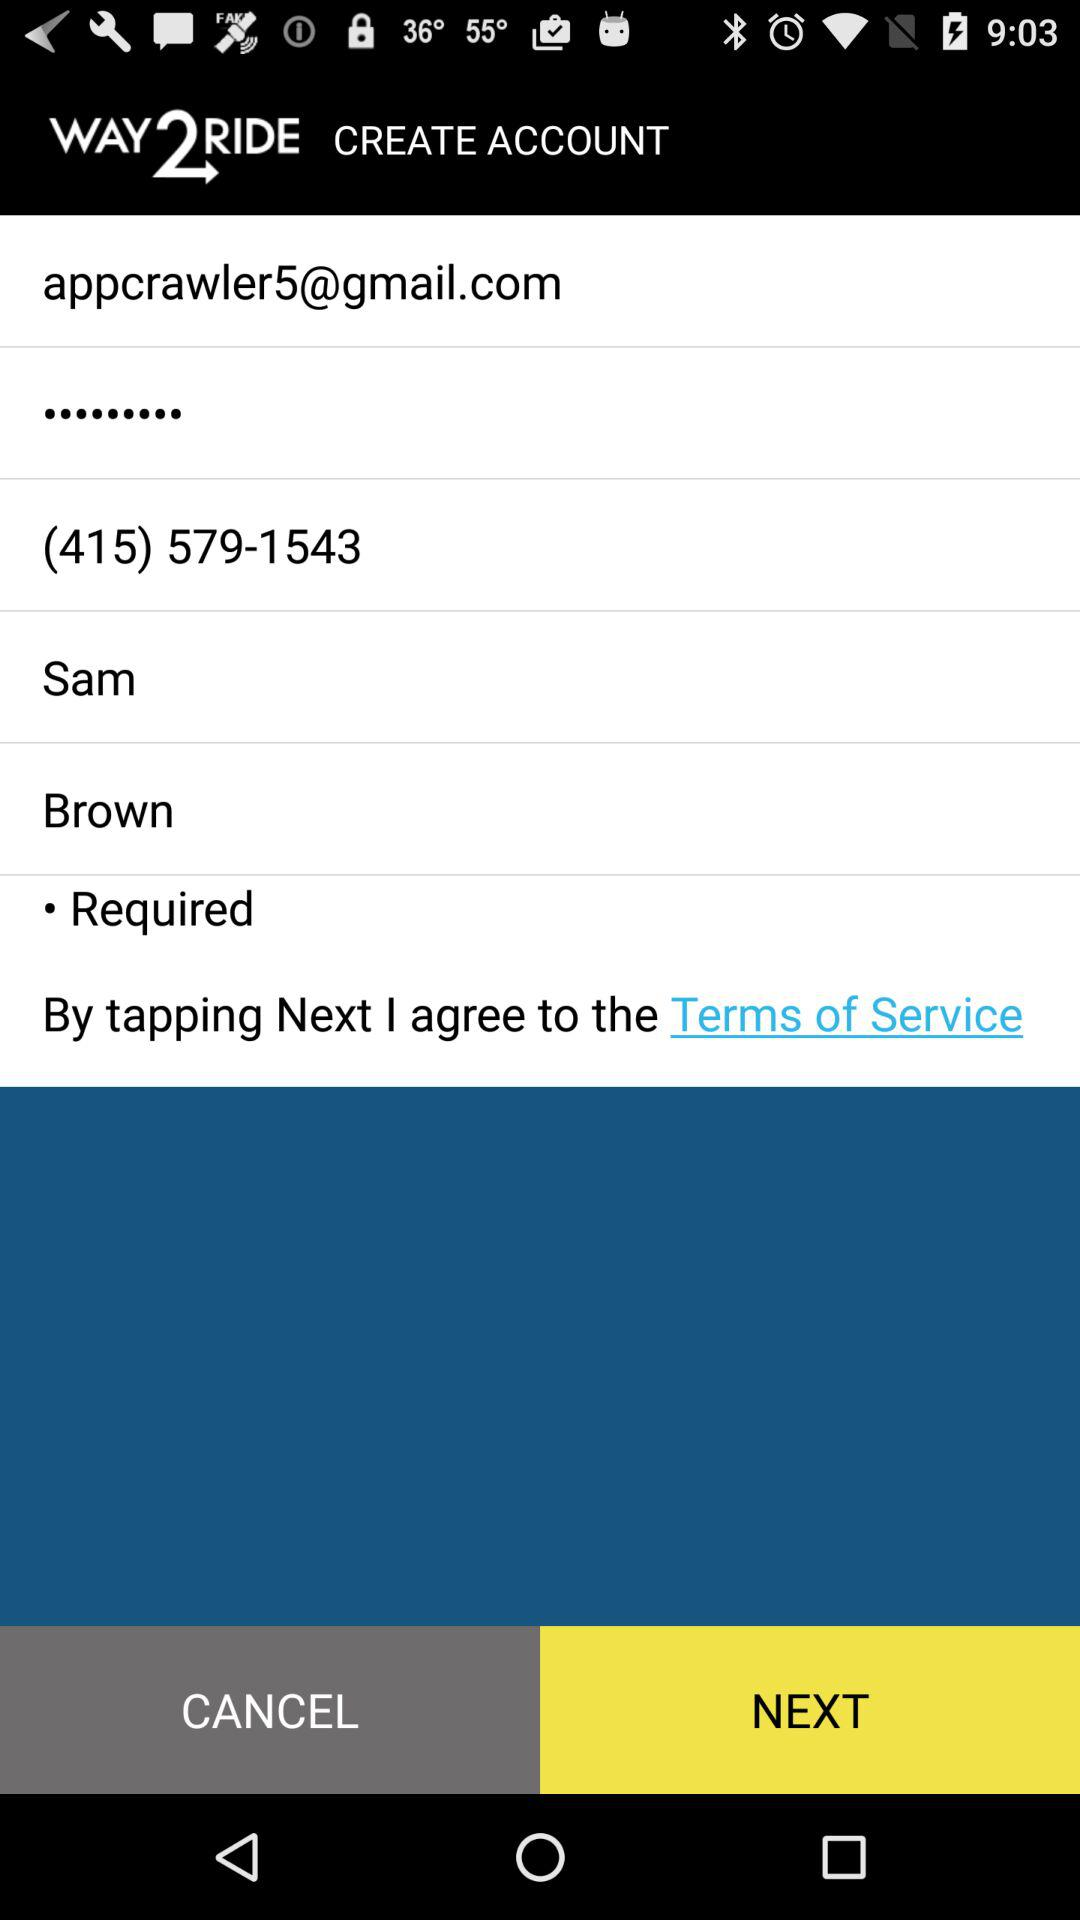What is the name of the person? The name of the person is Sam Brown. 